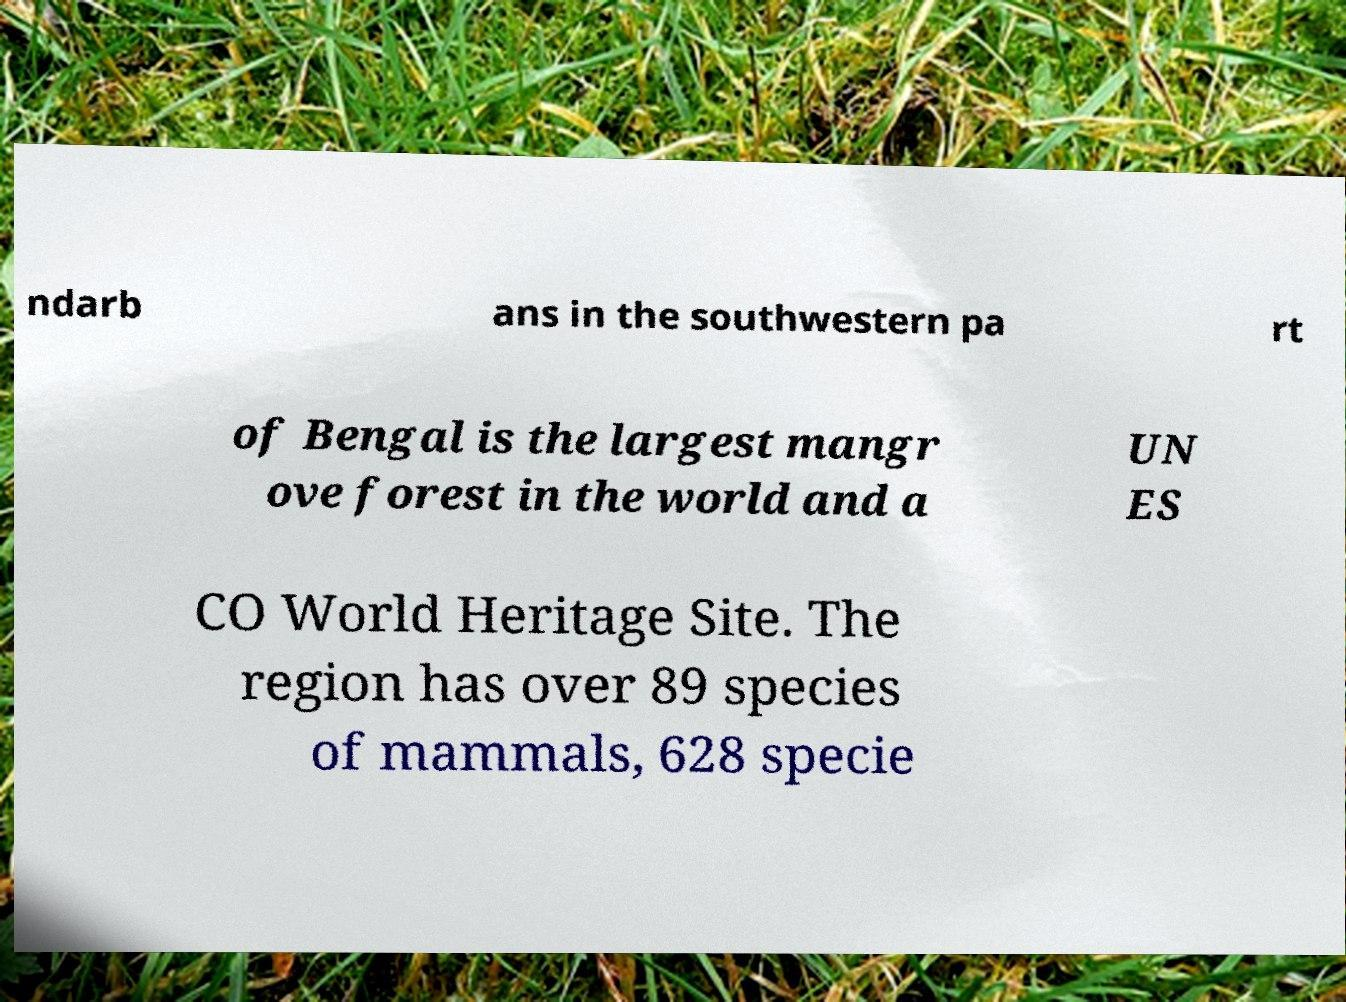Could you extract and type out the text from this image? ndarb ans in the southwestern pa rt of Bengal is the largest mangr ove forest in the world and a UN ES CO World Heritage Site. The region has over 89 species of mammals, 628 specie 